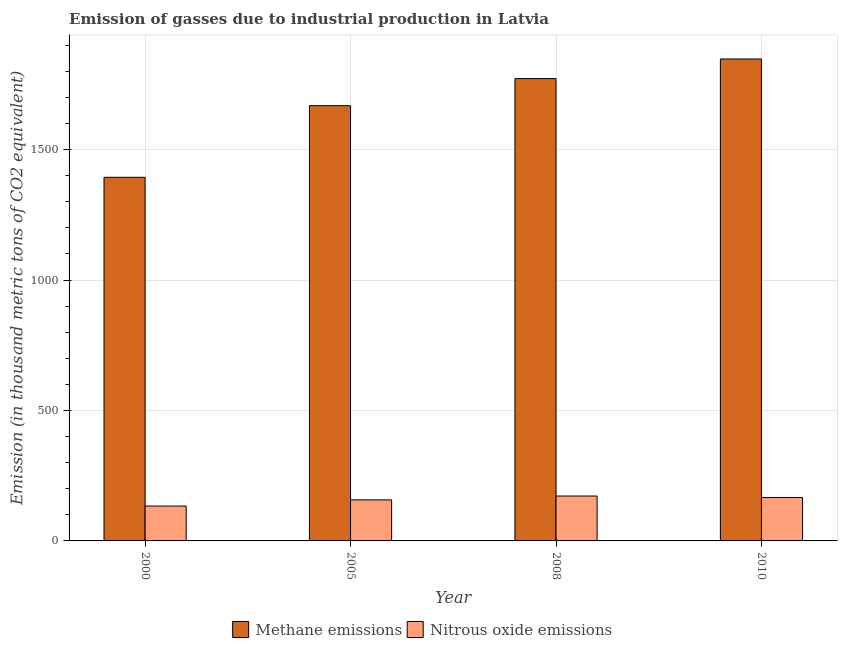How many groups of bars are there?
Make the answer very short. 4. Are the number of bars per tick equal to the number of legend labels?
Keep it short and to the point. Yes. Are the number of bars on each tick of the X-axis equal?
Make the answer very short. Yes. How many bars are there on the 2nd tick from the right?
Your answer should be compact. 2. What is the label of the 3rd group of bars from the left?
Offer a very short reply. 2008. In how many cases, is the number of bars for a given year not equal to the number of legend labels?
Your answer should be very brief. 0. What is the amount of nitrous oxide emissions in 2008?
Make the answer very short. 172.1. Across all years, what is the maximum amount of nitrous oxide emissions?
Your answer should be compact. 172.1. Across all years, what is the minimum amount of nitrous oxide emissions?
Provide a short and direct response. 133.7. In which year was the amount of methane emissions maximum?
Provide a succinct answer. 2010. What is the total amount of methane emissions in the graph?
Offer a terse response. 6681.7. What is the difference between the amount of methane emissions in 2000 and that in 2008?
Provide a short and direct response. -378.4. What is the difference between the amount of nitrous oxide emissions in 2005 and the amount of methane emissions in 2008?
Your response must be concise. -14.8. What is the average amount of methane emissions per year?
Your response must be concise. 1670.43. What is the ratio of the amount of methane emissions in 2000 to that in 2010?
Your answer should be compact. 0.75. Is the amount of nitrous oxide emissions in 2000 less than that in 2008?
Give a very brief answer. Yes. Is the difference between the amount of nitrous oxide emissions in 2000 and 2010 greater than the difference between the amount of methane emissions in 2000 and 2010?
Your answer should be very brief. No. What is the difference between the highest and the second highest amount of nitrous oxide emissions?
Ensure brevity in your answer.  5.8. What is the difference between the highest and the lowest amount of nitrous oxide emissions?
Make the answer very short. 38.4. What does the 2nd bar from the left in 2005 represents?
Your answer should be very brief. Nitrous oxide emissions. What does the 1st bar from the right in 2010 represents?
Offer a very short reply. Nitrous oxide emissions. How many bars are there?
Provide a short and direct response. 8. How many years are there in the graph?
Offer a terse response. 4. What is the difference between two consecutive major ticks on the Y-axis?
Give a very brief answer. 500. Are the values on the major ticks of Y-axis written in scientific E-notation?
Keep it short and to the point. No. Does the graph contain grids?
Offer a very short reply. Yes. How many legend labels are there?
Make the answer very short. 2. How are the legend labels stacked?
Offer a terse response. Horizontal. What is the title of the graph?
Keep it short and to the point. Emission of gasses due to industrial production in Latvia. Does "Young" appear as one of the legend labels in the graph?
Provide a short and direct response. No. What is the label or title of the X-axis?
Offer a very short reply. Year. What is the label or title of the Y-axis?
Offer a terse response. Emission (in thousand metric tons of CO2 equivalent). What is the Emission (in thousand metric tons of CO2 equivalent) of Methane emissions in 2000?
Provide a short and direct response. 1393.8. What is the Emission (in thousand metric tons of CO2 equivalent) in Nitrous oxide emissions in 2000?
Offer a terse response. 133.7. What is the Emission (in thousand metric tons of CO2 equivalent) in Methane emissions in 2005?
Your answer should be very brief. 1668.3. What is the Emission (in thousand metric tons of CO2 equivalent) of Nitrous oxide emissions in 2005?
Keep it short and to the point. 157.3. What is the Emission (in thousand metric tons of CO2 equivalent) in Methane emissions in 2008?
Your response must be concise. 1772.2. What is the Emission (in thousand metric tons of CO2 equivalent) in Nitrous oxide emissions in 2008?
Provide a succinct answer. 172.1. What is the Emission (in thousand metric tons of CO2 equivalent) in Methane emissions in 2010?
Your response must be concise. 1847.4. What is the Emission (in thousand metric tons of CO2 equivalent) of Nitrous oxide emissions in 2010?
Give a very brief answer. 166.3. Across all years, what is the maximum Emission (in thousand metric tons of CO2 equivalent) of Methane emissions?
Ensure brevity in your answer.  1847.4. Across all years, what is the maximum Emission (in thousand metric tons of CO2 equivalent) of Nitrous oxide emissions?
Provide a short and direct response. 172.1. Across all years, what is the minimum Emission (in thousand metric tons of CO2 equivalent) of Methane emissions?
Provide a succinct answer. 1393.8. Across all years, what is the minimum Emission (in thousand metric tons of CO2 equivalent) in Nitrous oxide emissions?
Keep it short and to the point. 133.7. What is the total Emission (in thousand metric tons of CO2 equivalent) in Methane emissions in the graph?
Keep it short and to the point. 6681.7. What is the total Emission (in thousand metric tons of CO2 equivalent) of Nitrous oxide emissions in the graph?
Ensure brevity in your answer.  629.4. What is the difference between the Emission (in thousand metric tons of CO2 equivalent) in Methane emissions in 2000 and that in 2005?
Give a very brief answer. -274.5. What is the difference between the Emission (in thousand metric tons of CO2 equivalent) in Nitrous oxide emissions in 2000 and that in 2005?
Provide a short and direct response. -23.6. What is the difference between the Emission (in thousand metric tons of CO2 equivalent) in Methane emissions in 2000 and that in 2008?
Your answer should be compact. -378.4. What is the difference between the Emission (in thousand metric tons of CO2 equivalent) of Nitrous oxide emissions in 2000 and that in 2008?
Your response must be concise. -38.4. What is the difference between the Emission (in thousand metric tons of CO2 equivalent) of Methane emissions in 2000 and that in 2010?
Keep it short and to the point. -453.6. What is the difference between the Emission (in thousand metric tons of CO2 equivalent) of Nitrous oxide emissions in 2000 and that in 2010?
Keep it short and to the point. -32.6. What is the difference between the Emission (in thousand metric tons of CO2 equivalent) in Methane emissions in 2005 and that in 2008?
Your response must be concise. -103.9. What is the difference between the Emission (in thousand metric tons of CO2 equivalent) in Nitrous oxide emissions in 2005 and that in 2008?
Your answer should be very brief. -14.8. What is the difference between the Emission (in thousand metric tons of CO2 equivalent) of Methane emissions in 2005 and that in 2010?
Provide a short and direct response. -179.1. What is the difference between the Emission (in thousand metric tons of CO2 equivalent) in Methane emissions in 2008 and that in 2010?
Your response must be concise. -75.2. What is the difference between the Emission (in thousand metric tons of CO2 equivalent) in Methane emissions in 2000 and the Emission (in thousand metric tons of CO2 equivalent) in Nitrous oxide emissions in 2005?
Provide a succinct answer. 1236.5. What is the difference between the Emission (in thousand metric tons of CO2 equivalent) in Methane emissions in 2000 and the Emission (in thousand metric tons of CO2 equivalent) in Nitrous oxide emissions in 2008?
Provide a succinct answer. 1221.7. What is the difference between the Emission (in thousand metric tons of CO2 equivalent) in Methane emissions in 2000 and the Emission (in thousand metric tons of CO2 equivalent) in Nitrous oxide emissions in 2010?
Provide a succinct answer. 1227.5. What is the difference between the Emission (in thousand metric tons of CO2 equivalent) in Methane emissions in 2005 and the Emission (in thousand metric tons of CO2 equivalent) in Nitrous oxide emissions in 2008?
Make the answer very short. 1496.2. What is the difference between the Emission (in thousand metric tons of CO2 equivalent) of Methane emissions in 2005 and the Emission (in thousand metric tons of CO2 equivalent) of Nitrous oxide emissions in 2010?
Provide a short and direct response. 1502. What is the difference between the Emission (in thousand metric tons of CO2 equivalent) of Methane emissions in 2008 and the Emission (in thousand metric tons of CO2 equivalent) of Nitrous oxide emissions in 2010?
Keep it short and to the point. 1605.9. What is the average Emission (in thousand metric tons of CO2 equivalent) in Methane emissions per year?
Your answer should be compact. 1670.42. What is the average Emission (in thousand metric tons of CO2 equivalent) of Nitrous oxide emissions per year?
Your response must be concise. 157.35. In the year 2000, what is the difference between the Emission (in thousand metric tons of CO2 equivalent) of Methane emissions and Emission (in thousand metric tons of CO2 equivalent) of Nitrous oxide emissions?
Offer a very short reply. 1260.1. In the year 2005, what is the difference between the Emission (in thousand metric tons of CO2 equivalent) of Methane emissions and Emission (in thousand metric tons of CO2 equivalent) of Nitrous oxide emissions?
Ensure brevity in your answer.  1511. In the year 2008, what is the difference between the Emission (in thousand metric tons of CO2 equivalent) in Methane emissions and Emission (in thousand metric tons of CO2 equivalent) in Nitrous oxide emissions?
Offer a very short reply. 1600.1. In the year 2010, what is the difference between the Emission (in thousand metric tons of CO2 equivalent) of Methane emissions and Emission (in thousand metric tons of CO2 equivalent) of Nitrous oxide emissions?
Provide a short and direct response. 1681.1. What is the ratio of the Emission (in thousand metric tons of CO2 equivalent) of Methane emissions in 2000 to that in 2005?
Offer a very short reply. 0.84. What is the ratio of the Emission (in thousand metric tons of CO2 equivalent) in Methane emissions in 2000 to that in 2008?
Offer a terse response. 0.79. What is the ratio of the Emission (in thousand metric tons of CO2 equivalent) of Nitrous oxide emissions in 2000 to that in 2008?
Your answer should be compact. 0.78. What is the ratio of the Emission (in thousand metric tons of CO2 equivalent) of Methane emissions in 2000 to that in 2010?
Your answer should be compact. 0.75. What is the ratio of the Emission (in thousand metric tons of CO2 equivalent) of Nitrous oxide emissions in 2000 to that in 2010?
Your answer should be compact. 0.8. What is the ratio of the Emission (in thousand metric tons of CO2 equivalent) in Methane emissions in 2005 to that in 2008?
Ensure brevity in your answer.  0.94. What is the ratio of the Emission (in thousand metric tons of CO2 equivalent) in Nitrous oxide emissions in 2005 to that in 2008?
Give a very brief answer. 0.91. What is the ratio of the Emission (in thousand metric tons of CO2 equivalent) in Methane emissions in 2005 to that in 2010?
Make the answer very short. 0.9. What is the ratio of the Emission (in thousand metric tons of CO2 equivalent) in Nitrous oxide emissions in 2005 to that in 2010?
Your answer should be very brief. 0.95. What is the ratio of the Emission (in thousand metric tons of CO2 equivalent) in Methane emissions in 2008 to that in 2010?
Your answer should be very brief. 0.96. What is the ratio of the Emission (in thousand metric tons of CO2 equivalent) of Nitrous oxide emissions in 2008 to that in 2010?
Provide a short and direct response. 1.03. What is the difference between the highest and the second highest Emission (in thousand metric tons of CO2 equivalent) of Methane emissions?
Offer a very short reply. 75.2. What is the difference between the highest and the second highest Emission (in thousand metric tons of CO2 equivalent) in Nitrous oxide emissions?
Give a very brief answer. 5.8. What is the difference between the highest and the lowest Emission (in thousand metric tons of CO2 equivalent) in Methane emissions?
Your response must be concise. 453.6. What is the difference between the highest and the lowest Emission (in thousand metric tons of CO2 equivalent) of Nitrous oxide emissions?
Keep it short and to the point. 38.4. 